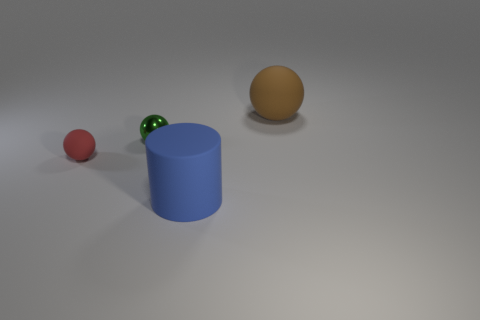Is there anything else that is the same material as the tiny green thing?
Offer a very short reply. No. Are the green object and the large cylinder made of the same material?
Make the answer very short. No. What is the shape of the thing that is to the right of the large object that is in front of the matte thing to the left of the tiny shiny object?
Provide a short and direct response. Sphere. Are there fewer big blue cylinders that are on the left side of the metal ball than tiny shiny spheres left of the small rubber object?
Your response must be concise. No. There is a big rubber thing that is in front of the matte ball that is in front of the big brown rubber sphere; what shape is it?
Offer a very short reply. Cylinder. Is there anything else of the same color as the small matte object?
Make the answer very short. No. Is the color of the small rubber ball the same as the cylinder?
Offer a very short reply. No. How many gray objects are either small metallic balls or matte things?
Ensure brevity in your answer.  0. Are there fewer balls left of the cylinder than yellow metallic cylinders?
Your response must be concise. No. There is a large rubber thing in front of the small matte object; what number of things are to the left of it?
Keep it short and to the point. 2. 